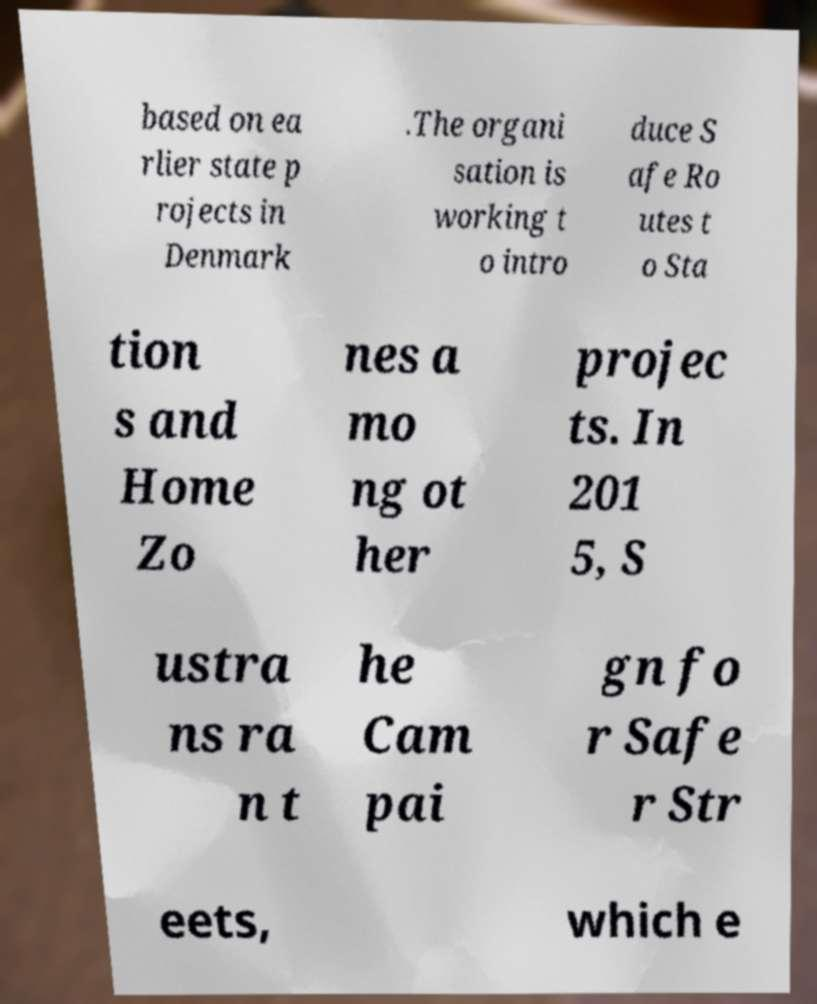Please identify and transcribe the text found in this image. based on ea rlier state p rojects in Denmark .The organi sation is working t o intro duce S afe Ro utes t o Sta tion s and Home Zo nes a mo ng ot her projec ts. In 201 5, S ustra ns ra n t he Cam pai gn fo r Safe r Str eets, which e 